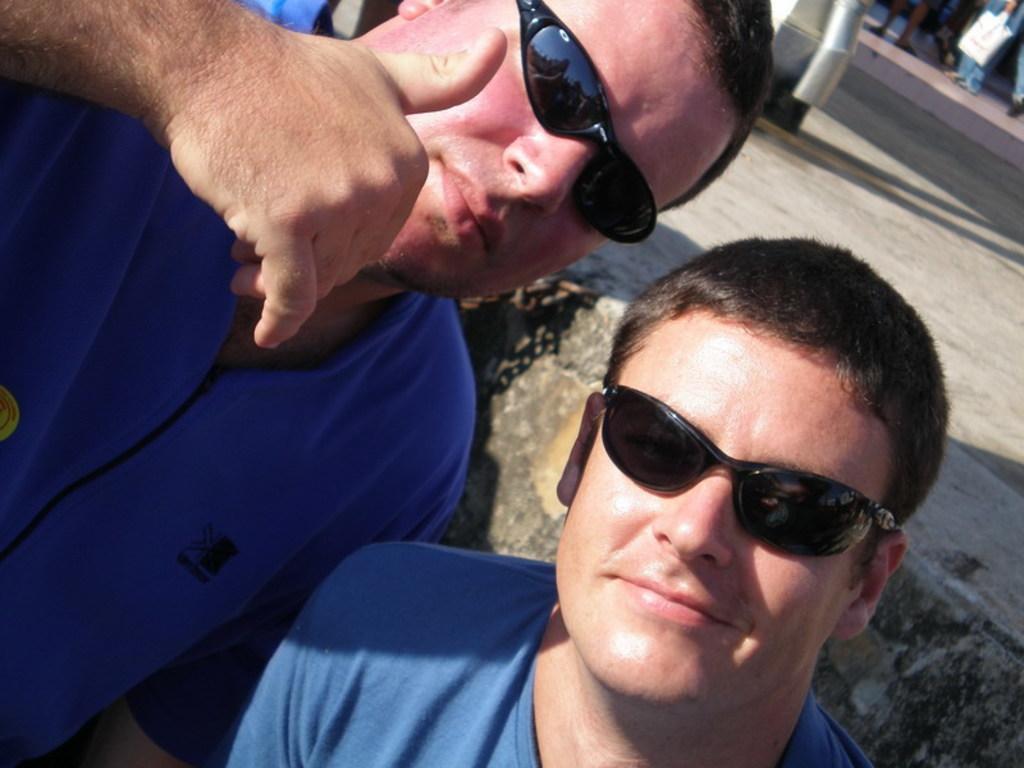Can you describe this image briefly? In this image I can see two men and I can see both of them are wearing blue dress and black shades. Over there I can see few people are standing. 